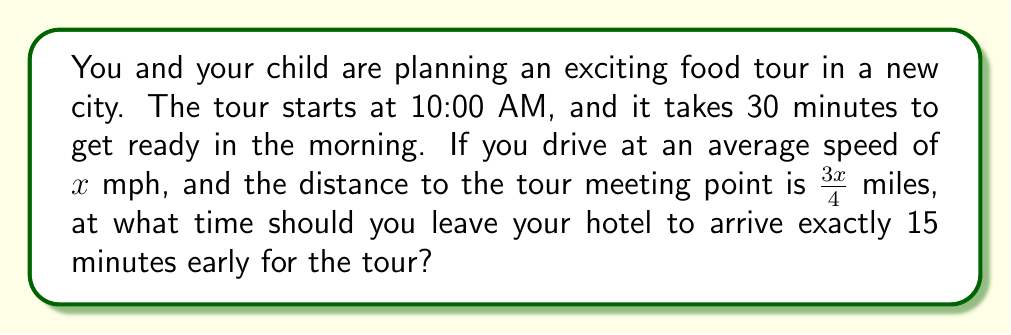Give your solution to this math problem. Let's approach this step-by-step:

1) First, we need to calculate the travel time. We know:
   - Distance = $\frac{3x}{4}$ miles
   - Speed = $x$ mph

   Using the formula: Time = Distance / Speed
   Travel time = $\frac{3x/4}{x} = \frac{3}{4}$ hours

2) Convert 3/4 hours to minutes:
   $\frac{3}{4} \times 60 = 45$ minutes

3) Now, let's work backwards from the tour start time:
   - Tour start time: 10:00 AM
   - Aim to arrive 15 minutes early: 9:45 AM
   - Travel time: 45 minutes
   - Getting ready time: 30 minutes

4) Calculate the leaving time:
   9:45 AM - 45 minutes (travel) - 30 minutes (getting ready) = 8:30 AM

Therefore, you should leave the hotel at 8:30 AM to arrive 15 minutes early for the tour.
Answer: 8:30 AM 